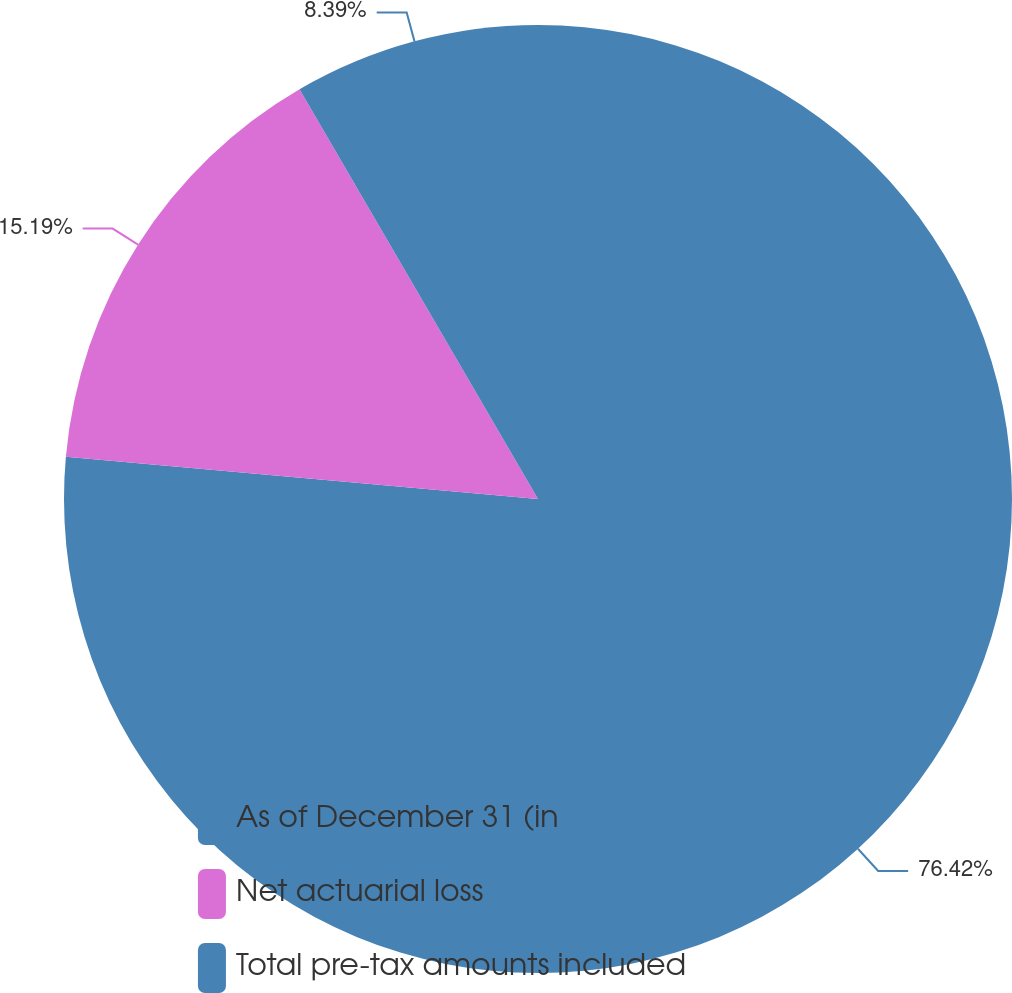<chart> <loc_0><loc_0><loc_500><loc_500><pie_chart><fcel>As of December 31 (in<fcel>Net actuarial loss<fcel>Total pre-tax amounts included<nl><fcel>76.41%<fcel>15.19%<fcel>8.39%<nl></chart> 